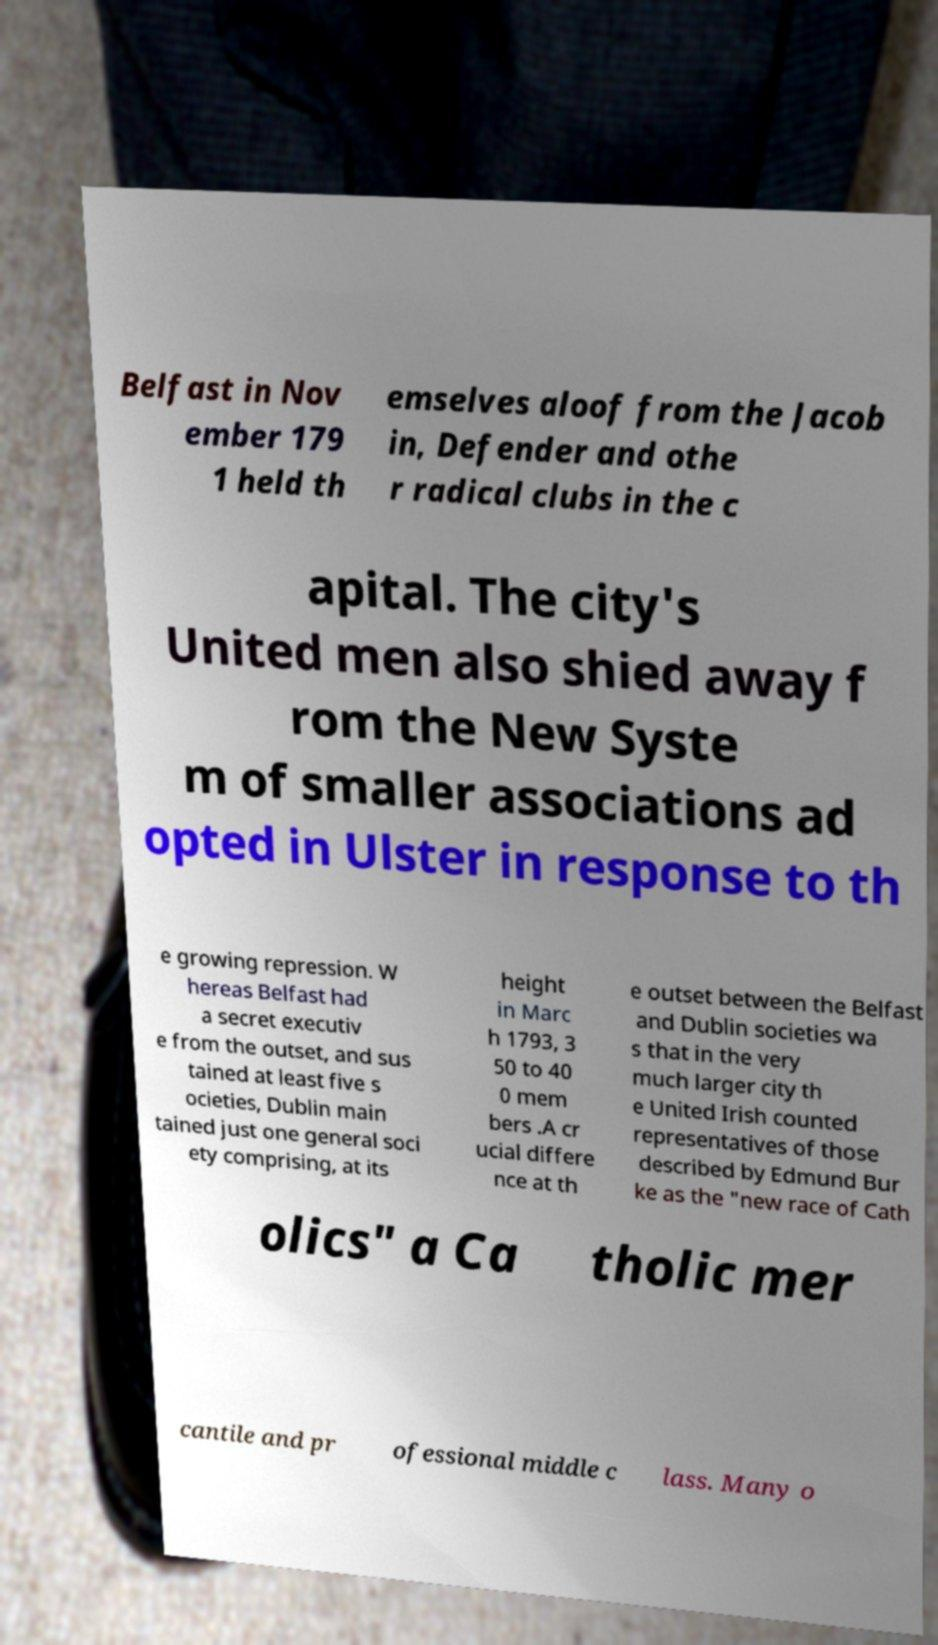For documentation purposes, I need the text within this image transcribed. Could you provide that? Belfast in Nov ember 179 1 held th emselves aloof from the Jacob in, Defender and othe r radical clubs in the c apital. The city's United men also shied away f rom the New Syste m of smaller associations ad opted in Ulster in response to th e growing repression. W hereas Belfast had a secret executiv e from the outset, and sus tained at least five s ocieties, Dublin main tained just one general soci ety comprising, at its height in Marc h 1793, 3 50 to 40 0 mem bers .A cr ucial differe nce at th e outset between the Belfast and Dublin societies wa s that in the very much larger city th e United Irish counted representatives of those described by Edmund Bur ke as the "new race of Cath olics" a Ca tholic mer cantile and pr ofessional middle c lass. Many o 